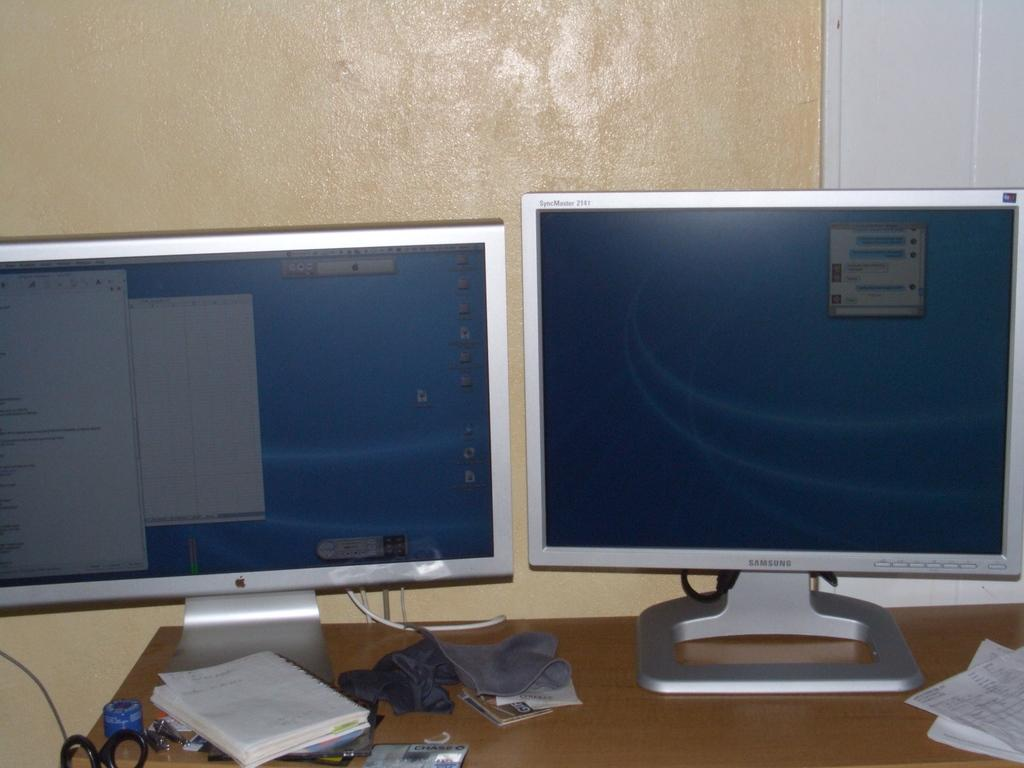Provide a one-sentence caption for the provided image. an apple monitor and a samsung monitor on a desk. 